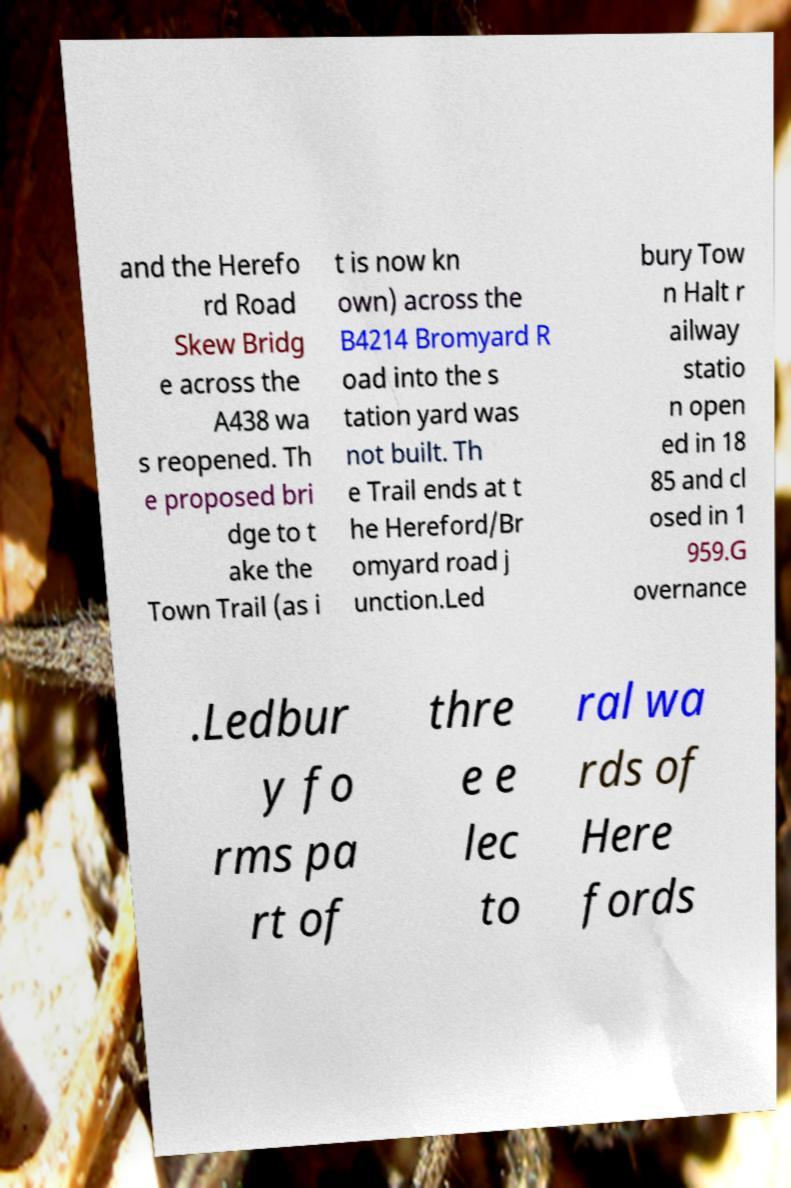For documentation purposes, I need the text within this image transcribed. Could you provide that? and the Herefo rd Road Skew Bridg e across the A438 wa s reopened. Th e proposed bri dge to t ake the Town Trail (as i t is now kn own) across the B4214 Bromyard R oad into the s tation yard was not built. Th e Trail ends at t he Hereford/Br omyard road j unction.Led bury Tow n Halt r ailway statio n open ed in 18 85 and cl osed in 1 959.G overnance .Ledbur y fo rms pa rt of thre e e lec to ral wa rds of Here fords 